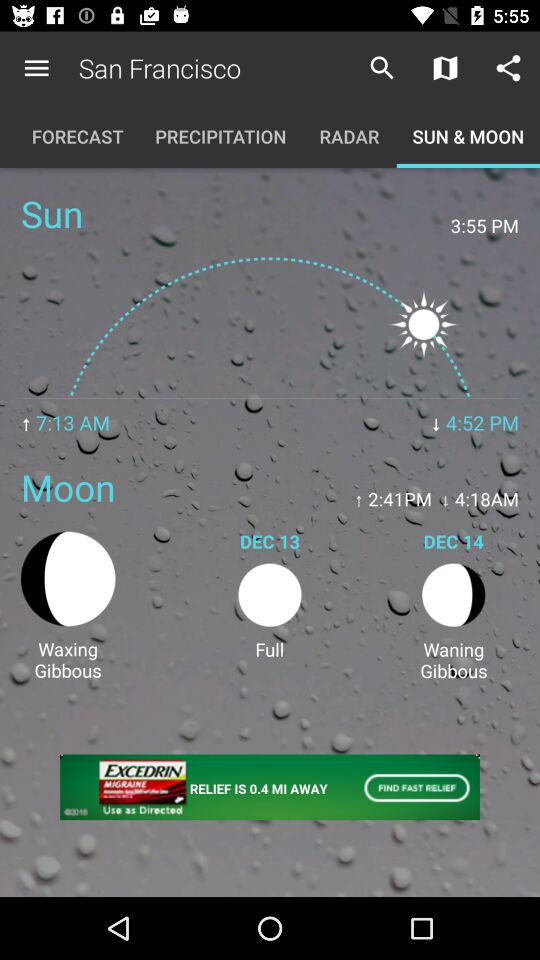Which option is selected in San Francisco? The selected option is "SUN & MOON". 